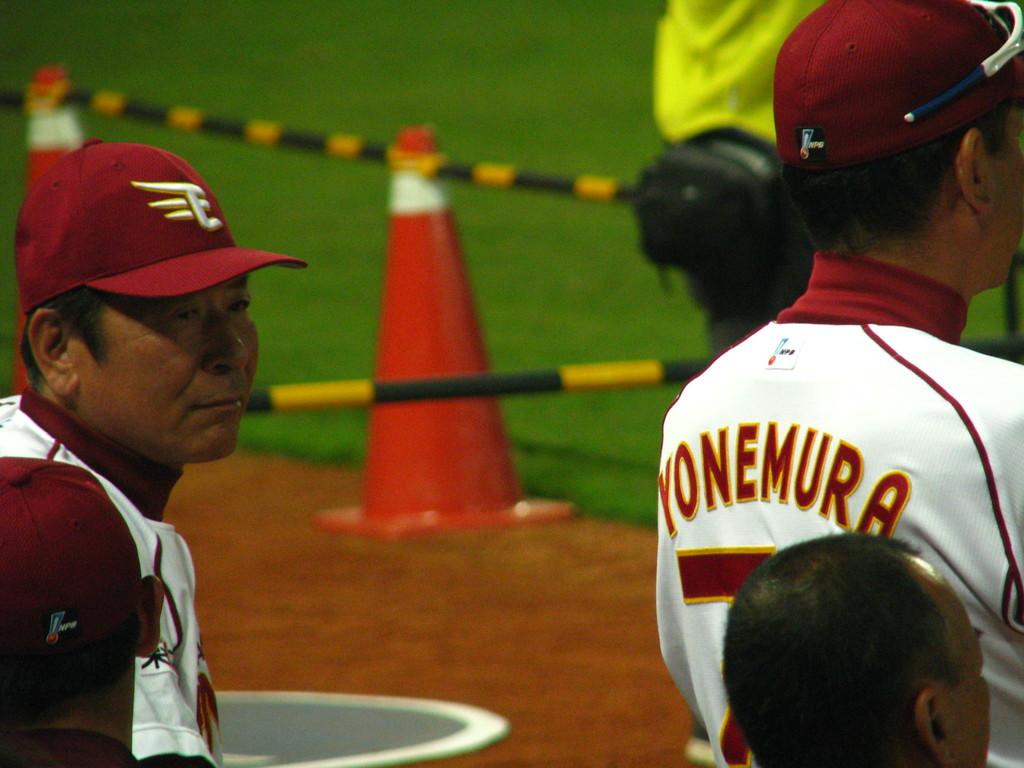What is the name of the player?
Provide a short and direct response. Yonemura. What letter is on the hat?
Keep it short and to the point. E. 